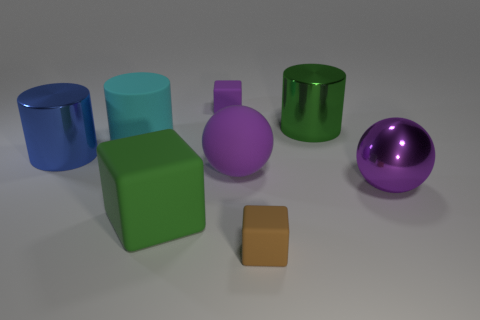Subtract all red spheres. Subtract all green blocks. How many spheres are left? 2 Add 1 brown matte blocks. How many objects exist? 9 Subtract all cylinders. How many objects are left? 5 Add 1 large blue objects. How many large blue objects are left? 2 Add 1 brown metallic blocks. How many brown metallic blocks exist? 1 Subtract 0 brown cylinders. How many objects are left? 8 Subtract all blue things. Subtract all tiny rubber objects. How many objects are left? 5 